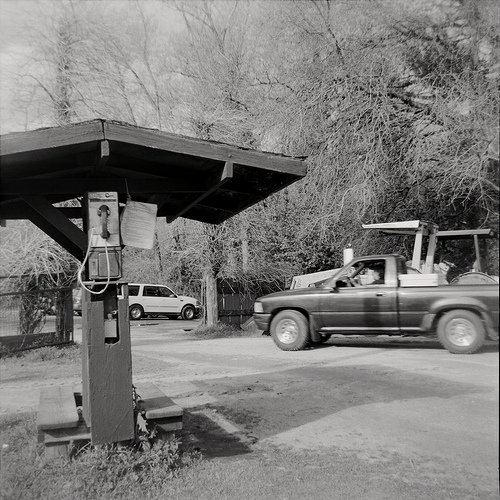Please provide a short description for this region: [0.68, 0.52, 0.76, 0.57]. The region [0.68, 0.52, 0.76, 0.57] captures a man sitting inside a truck, likely driving or parked nearby. 